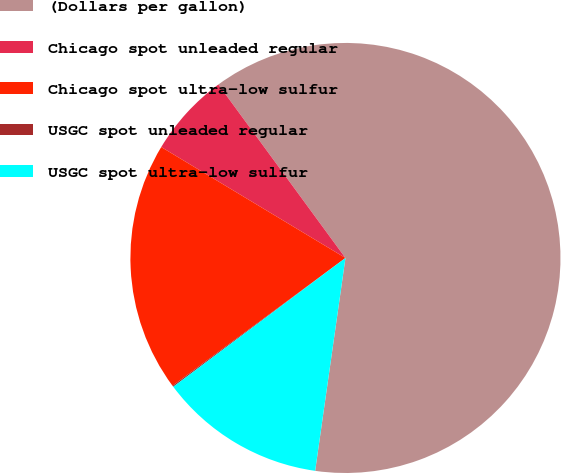Convert chart. <chart><loc_0><loc_0><loc_500><loc_500><pie_chart><fcel>(Dollars per gallon)<fcel>Chicago spot unleaded regular<fcel>Chicago spot ultra-low sulfur<fcel>USGC spot unleaded regular<fcel>USGC spot ultra-low sulfur<nl><fcel>62.32%<fcel>6.31%<fcel>18.76%<fcel>0.09%<fcel>12.53%<nl></chart> 